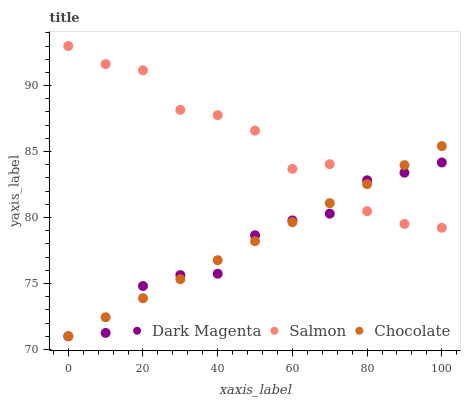Does Dark Magenta have the minimum area under the curve?
Answer yes or no. Yes. Does Salmon have the maximum area under the curve?
Answer yes or no. Yes. Does Chocolate have the minimum area under the curve?
Answer yes or no. No. Does Chocolate have the maximum area under the curve?
Answer yes or no. No. Is Chocolate the smoothest?
Answer yes or no. Yes. Is Salmon the roughest?
Answer yes or no. Yes. Is Dark Magenta the smoothest?
Answer yes or no. No. Is Dark Magenta the roughest?
Answer yes or no. No. Does Dark Magenta have the lowest value?
Answer yes or no. Yes. Does Salmon have the highest value?
Answer yes or no. Yes. Does Chocolate have the highest value?
Answer yes or no. No. Does Dark Magenta intersect Chocolate?
Answer yes or no. Yes. Is Dark Magenta less than Chocolate?
Answer yes or no. No. Is Dark Magenta greater than Chocolate?
Answer yes or no. No. 